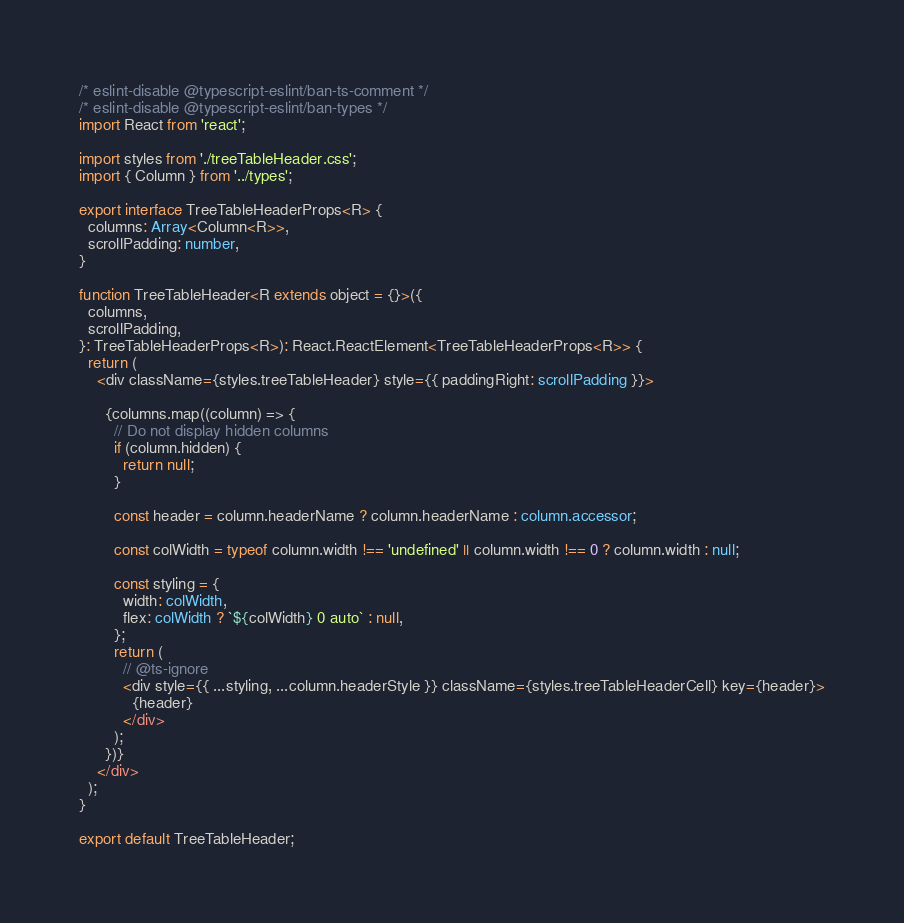Convert code to text. <code><loc_0><loc_0><loc_500><loc_500><_TypeScript_>/* eslint-disable @typescript-eslint/ban-ts-comment */
/* eslint-disable @typescript-eslint/ban-types */
import React from 'react';

import styles from './treeTableHeader.css';
import { Column } from '../types';

export interface TreeTableHeaderProps<R> {
  columns: Array<Column<R>>,
  scrollPadding: number,
}

function TreeTableHeader<R extends object = {}>({
  columns,
  scrollPadding,
}: TreeTableHeaderProps<R>): React.ReactElement<TreeTableHeaderProps<R>> {
  return (
    <div className={styles.treeTableHeader} style={{ paddingRight: scrollPadding }}>

      {columns.map((column) => {
        // Do not display hidden columns
        if (column.hidden) {
          return null;
        }

        const header = column.headerName ? column.headerName : column.accessor;

        const colWidth = typeof column.width !== 'undefined' || column.width !== 0 ? column.width : null;

        const styling = {
          width: colWidth,
          flex: colWidth ? `${colWidth} 0 auto` : null,
        };
        return (
          // @ts-ignore
          <div style={{ ...styling, ...column.headerStyle }} className={styles.treeTableHeaderCell} key={header}>
            {header}
          </div>
        );
      })}
    </div>
  );
}

export default TreeTableHeader;
</code> 